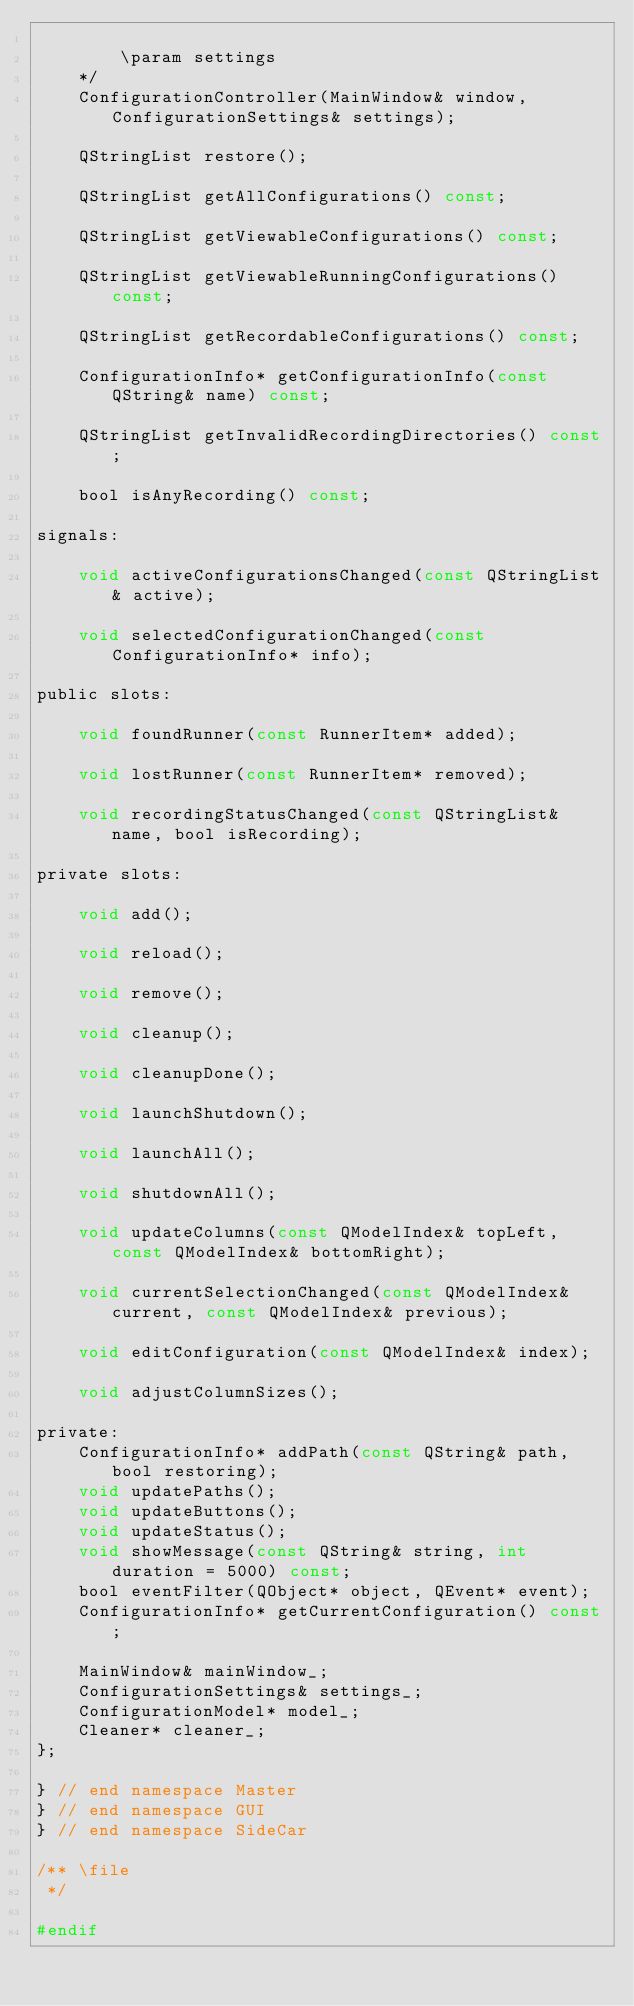<code> <loc_0><loc_0><loc_500><loc_500><_C_>
        \param settings
    */
    ConfigurationController(MainWindow& window, ConfigurationSettings& settings);

    QStringList restore();

    QStringList getAllConfigurations() const;

    QStringList getViewableConfigurations() const;

    QStringList getViewableRunningConfigurations() const;

    QStringList getRecordableConfigurations() const;

    ConfigurationInfo* getConfigurationInfo(const QString& name) const;

    QStringList getInvalidRecordingDirectories() const;

    bool isAnyRecording() const;

signals:

    void activeConfigurationsChanged(const QStringList& active);

    void selectedConfigurationChanged(const ConfigurationInfo* info);

public slots:

    void foundRunner(const RunnerItem* added);

    void lostRunner(const RunnerItem* removed);

    void recordingStatusChanged(const QStringList& name, bool isRecording);

private slots:

    void add();

    void reload();

    void remove();

    void cleanup();

    void cleanupDone();

    void launchShutdown();

    void launchAll();

    void shutdownAll();

    void updateColumns(const QModelIndex& topLeft, const QModelIndex& bottomRight);

    void currentSelectionChanged(const QModelIndex& current, const QModelIndex& previous);

    void editConfiguration(const QModelIndex& index);

    void adjustColumnSizes();

private:
    ConfigurationInfo* addPath(const QString& path, bool restoring);
    void updatePaths();
    void updateButtons();
    void updateStatus();
    void showMessage(const QString& string, int duration = 5000) const;
    bool eventFilter(QObject* object, QEvent* event);
    ConfigurationInfo* getCurrentConfiguration() const;

    MainWindow& mainWindow_;
    ConfigurationSettings& settings_;
    ConfigurationModel* model_;
    Cleaner* cleaner_;
};

} // end namespace Master
} // end namespace GUI
} // end namespace SideCar

/** \file
 */

#endif
</code> 